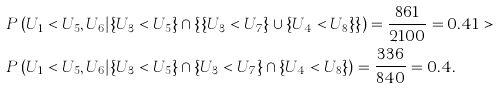<formula> <loc_0><loc_0><loc_500><loc_500>& P \left ( U _ { 1 } < U _ { 5 } , U _ { 6 } | \{ U _ { 3 } < U _ { 5 } \} \cap \left \{ \{ U _ { 3 } < U _ { 7 } \} \cup \{ U _ { 4 } < U _ { 8 } \} \right \} \right ) = \frac { 8 6 1 } { 2 1 0 0 } = 0 . 4 1 > \\ & P \left ( U _ { 1 } < U _ { 5 } , U _ { 6 } | \{ U _ { 3 } < U _ { 5 } \} \cap \{ U _ { 3 } < U _ { 7 } \} \cap \{ U _ { 4 } < U _ { 8 } \} \right ) = \frac { 3 3 6 } { 8 4 0 } = 0 . 4 .</formula> 